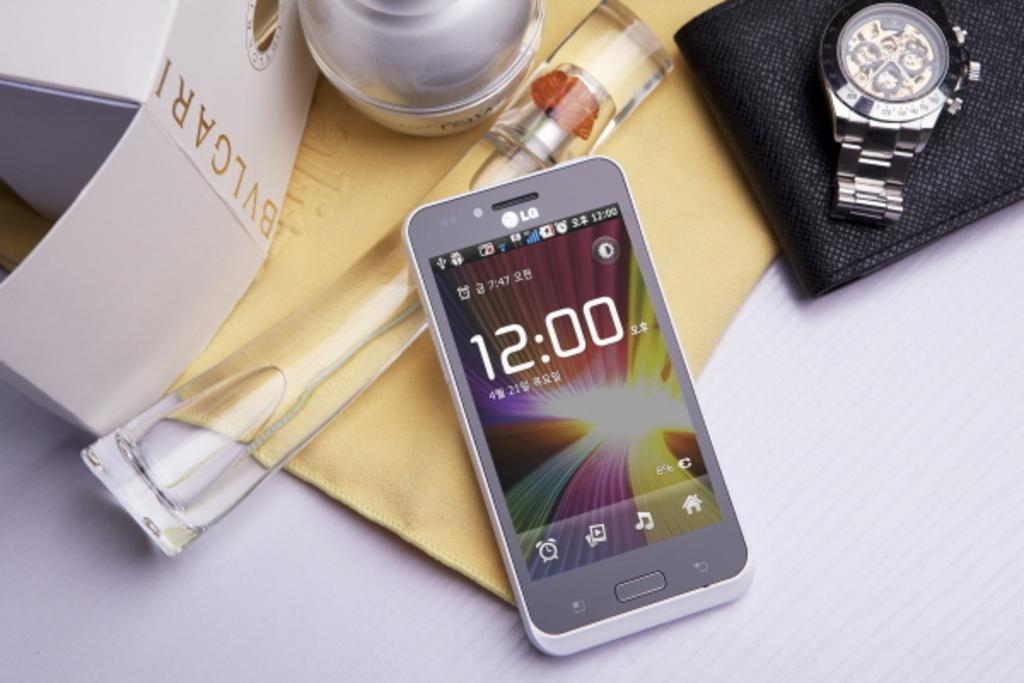<image>
Summarize the visual content of the image. A phone screen says that the time is exactly 12:00. 